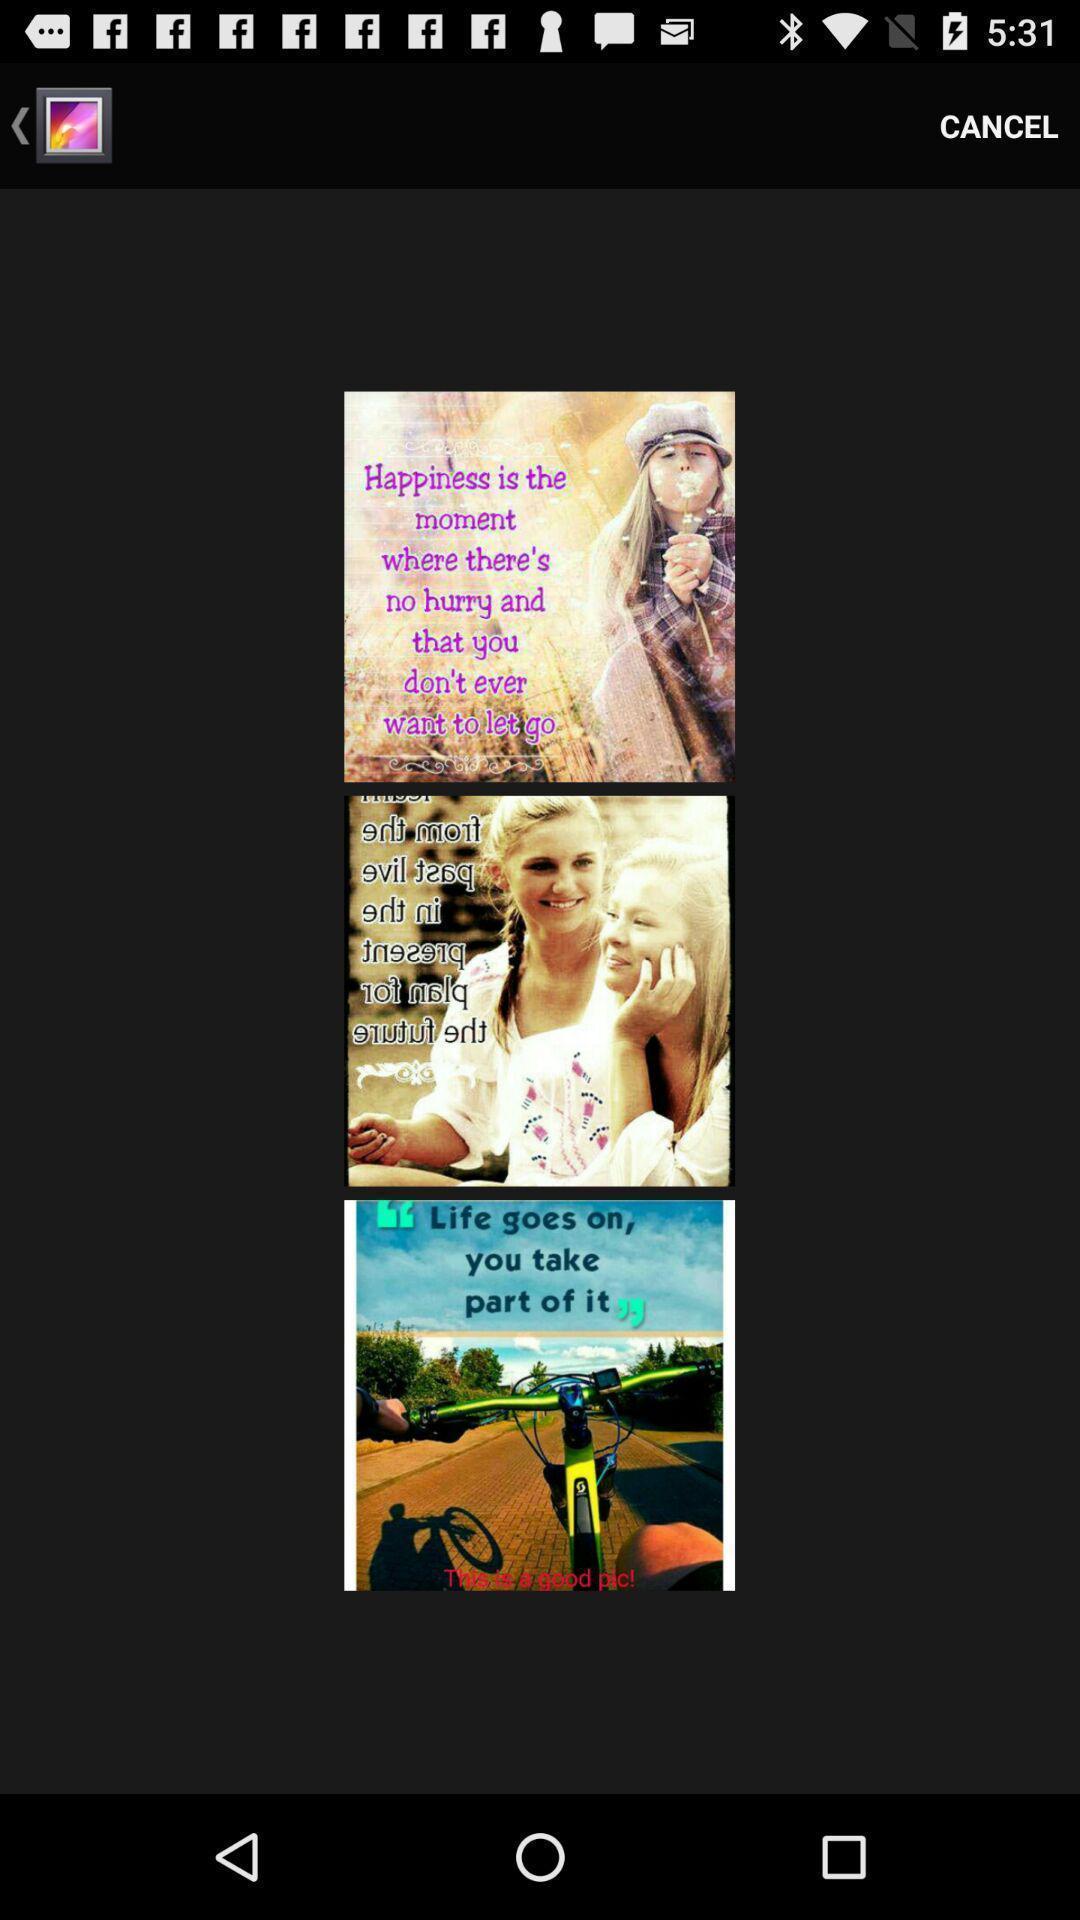Summarize the information in this screenshot. Quotes images displaying in gallery. 